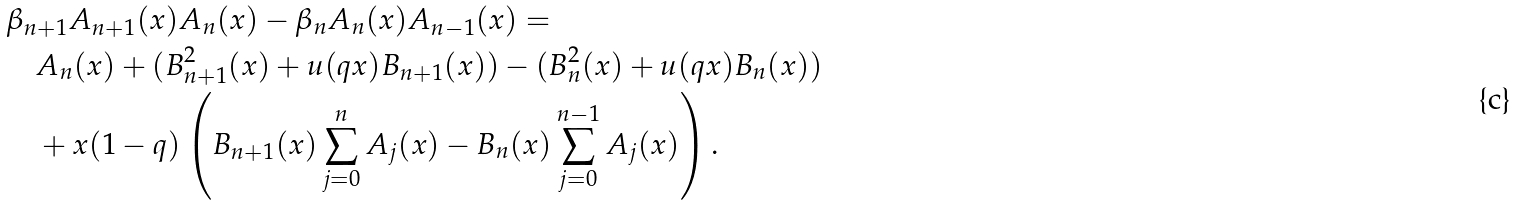<formula> <loc_0><loc_0><loc_500><loc_500>& \beta _ { n + 1 } A _ { n + 1 } ( x ) A _ { n } ( x ) - \beta _ { n } A _ { n } ( x ) A _ { n - 1 } ( x ) = \\ & \quad A _ { n } ( x ) + ( B _ { n + 1 } ^ { 2 } ( x ) + u ( q x ) B _ { n + 1 } ( x ) ) - ( B _ { n } ^ { 2 } ( x ) + u ( q x ) B _ { n } ( x ) ) \\ & \quad + x ( 1 - q ) \left ( B _ { n + 1 } ( x ) \sum _ { j = 0 } ^ { n } A _ { j } ( x ) - B _ { n } ( x ) \sum _ { j = 0 } ^ { n - 1 } A _ { j } ( x ) \right ) .</formula> 